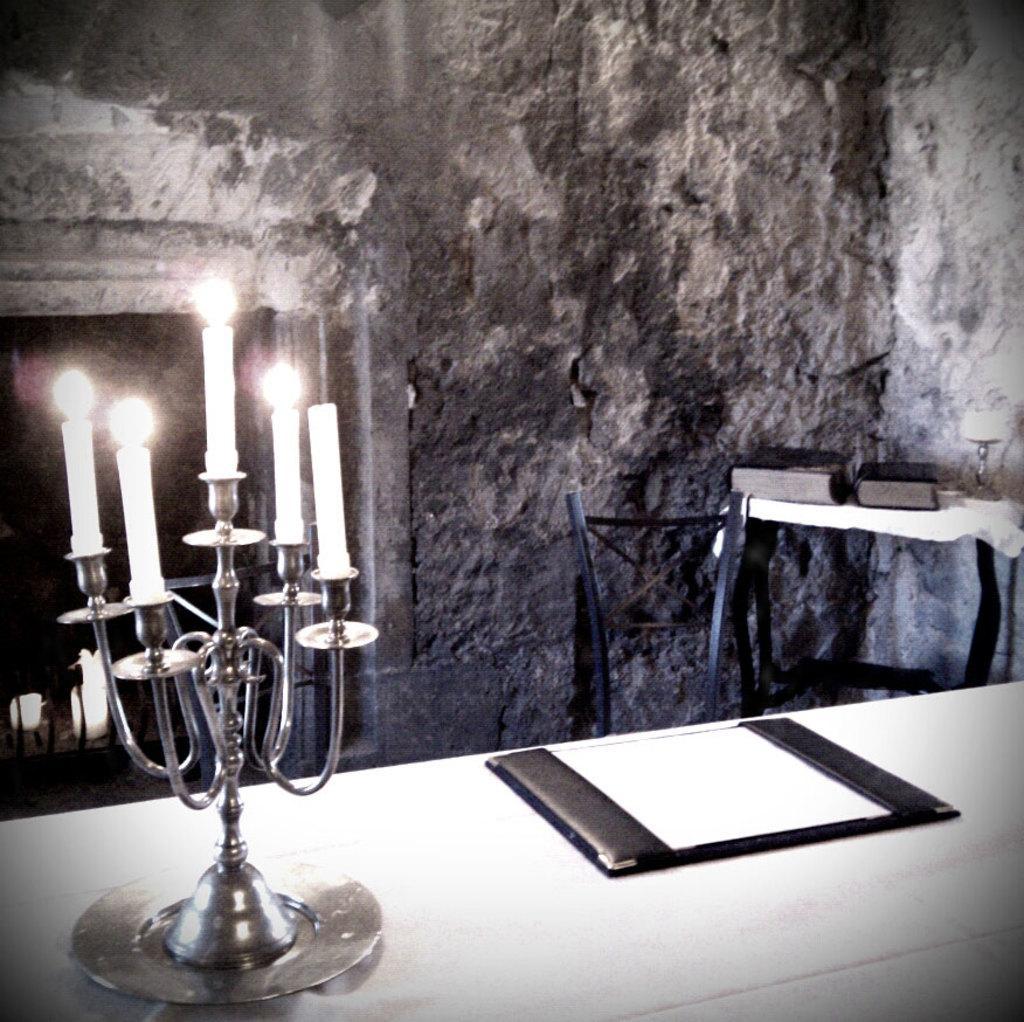Please provide a concise description of this image. In this picture we can see candles and a card on the table. This is the chair and there are books on the table. And this is the wall. 